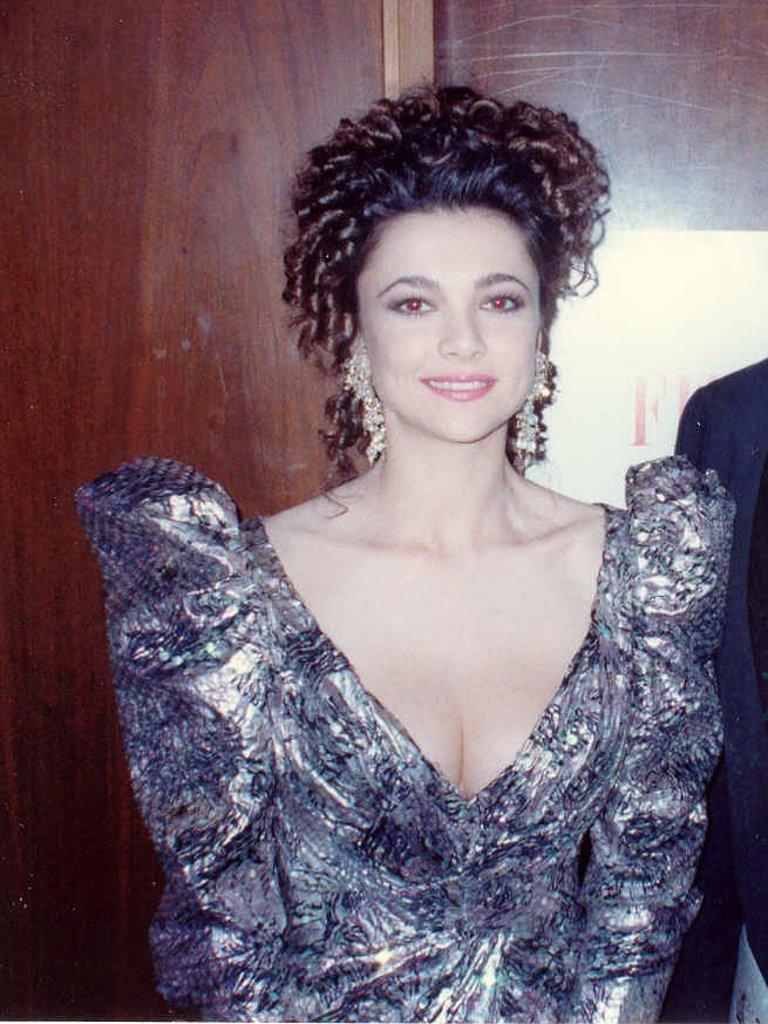Describe this image in one or two sentences. In this image I can see the person with the dress. In the background I can see the poster attached to the wooden wall. 